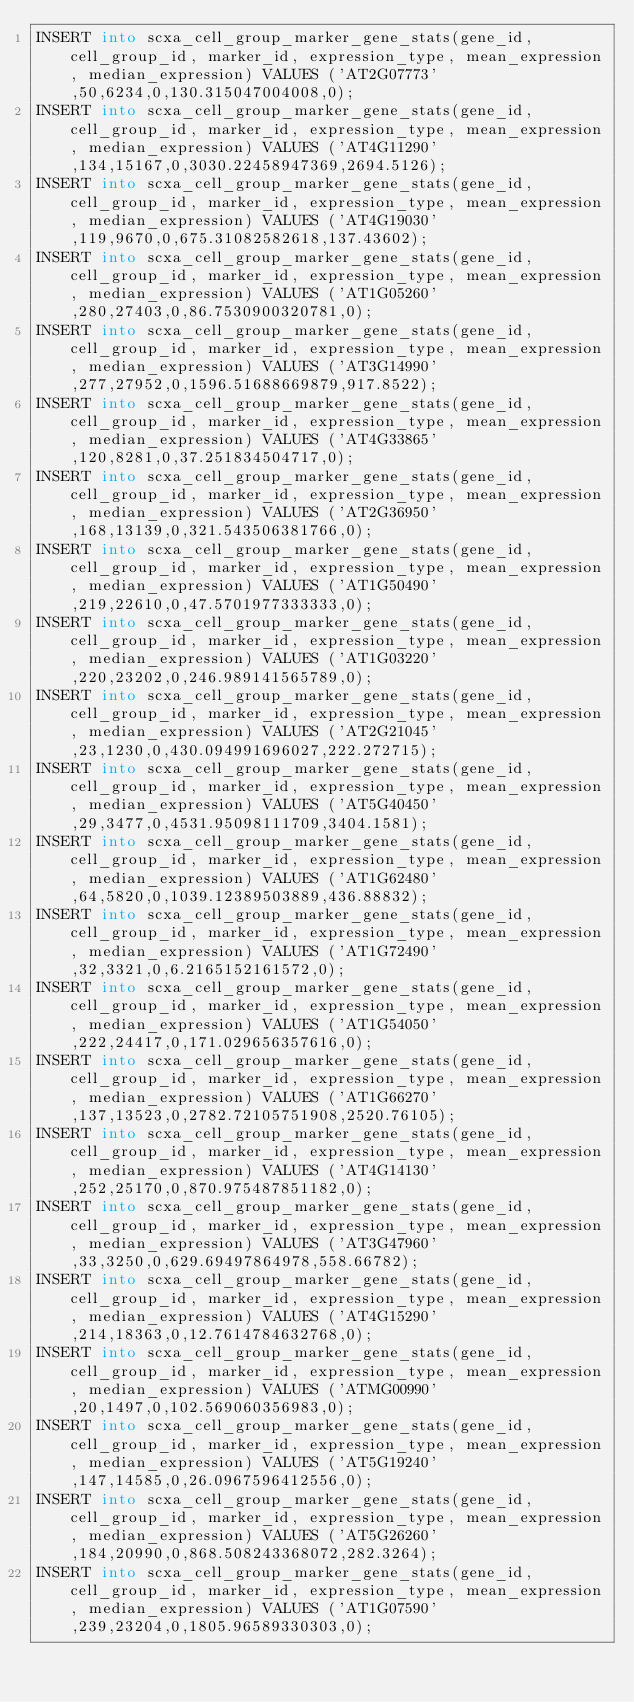Convert code to text. <code><loc_0><loc_0><loc_500><loc_500><_SQL_>INSERT into scxa_cell_group_marker_gene_stats(gene_id, cell_group_id, marker_id, expression_type, mean_expression, median_expression) VALUES ('AT2G07773',50,6234,0,130.315047004008,0);
INSERT into scxa_cell_group_marker_gene_stats(gene_id, cell_group_id, marker_id, expression_type, mean_expression, median_expression) VALUES ('AT4G11290',134,15167,0,3030.22458947369,2694.5126);
INSERT into scxa_cell_group_marker_gene_stats(gene_id, cell_group_id, marker_id, expression_type, mean_expression, median_expression) VALUES ('AT4G19030',119,9670,0,675.31082582618,137.43602);
INSERT into scxa_cell_group_marker_gene_stats(gene_id, cell_group_id, marker_id, expression_type, mean_expression, median_expression) VALUES ('AT1G05260',280,27403,0,86.7530900320781,0);
INSERT into scxa_cell_group_marker_gene_stats(gene_id, cell_group_id, marker_id, expression_type, mean_expression, median_expression) VALUES ('AT3G14990',277,27952,0,1596.51688669879,917.8522);
INSERT into scxa_cell_group_marker_gene_stats(gene_id, cell_group_id, marker_id, expression_type, mean_expression, median_expression) VALUES ('AT4G33865',120,8281,0,37.251834504717,0);
INSERT into scxa_cell_group_marker_gene_stats(gene_id, cell_group_id, marker_id, expression_type, mean_expression, median_expression) VALUES ('AT2G36950',168,13139,0,321.543506381766,0);
INSERT into scxa_cell_group_marker_gene_stats(gene_id, cell_group_id, marker_id, expression_type, mean_expression, median_expression) VALUES ('AT1G50490',219,22610,0,47.5701977333333,0);
INSERT into scxa_cell_group_marker_gene_stats(gene_id, cell_group_id, marker_id, expression_type, mean_expression, median_expression) VALUES ('AT1G03220',220,23202,0,246.989141565789,0);
INSERT into scxa_cell_group_marker_gene_stats(gene_id, cell_group_id, marker_id, expression_type, mean_expression, median_expression) VALUES ('AT2G21045',23,1230,0,430.094991696027,222.272715);
INSERT into scxa_cell_group_marker_gene_stats(gene_id, cell_group_id, marker_id, expression_type, mean_expression, median_expression) VALUES ('AT5G40450',29,3477,0,4531.95098111709,3404.1581);
INSERT into scxa_cell_group_marker_gene_stats(gene_id, cell_group_id, marker_id, expression_type, mean_expression, median_expression) VALUES ('AT1G62480',64,5820,0,1039.12389503889,436.88832);
INSERT into scxa_cell_group_marker_gene_stats(gene_id, cell_group_id, marker_id, expression_type, mean_expression, median_expression) VALUES ('AT1G72490',32,3321,0,6.2165152161572,0);
INSERT into scxa_cell_group_marker_gene_stats(gene_id, cell_group_id, marker_id, expression_type, mean_expression, median_expression) VALUES ('AT1G54050',222,24417,0,171.029656357616,0);
INSERT into scxa_cell_group_marker_gene_stats(gene_id, cell_group_id, marker_id, expression_type, mean_expression, median_expression) VALUES ('AT1G66270',137,13523,0,2782.72105751908,2520.76105);
INSERT into scxa_cell_group_marker_gene_stats(gene_id, cell_group_id, marker_id, expression_type, mean_expression, median_expression) VALUES ('AT4G14130',252,25170,0,870.975487851182,0);
INSERT into scxa_cell_group_marker_gene_stats(gene_id, cell_group_id, marker_id, expression_type, mean_expression, median_expression) VALUES ('AT3G47960',33,3250,0,629.69497864978,558.66782);
INSERT into scxa_cell_group_marker_gene_stats(gene_id, cell_group_id, marker_id, expression_type, mean_expression, median_expression) VALUES ('AT4G15290',214,18363,0,12.7614784632768,0);
INSERT into scxa_cell_group_marker_gene_stats(gene_id, cell_group_id, marker_id, expression_type, mean_expression, median_expression) VALUES ('ATMG00990',20,1497,0,102.569060356983,0);
INSERT into scxa_cell_group_marker_gene_stats(gene_id, cell_group_id, marker_id, expression_type, mean_expression, median_expression) VALUES ('AT5G19240',147,14585,0,26.0967596412556,0);
INSERT into scxa_cell_group_marker_gene_stats(gene_id, cell_group_id, marker_id, expression_type, mean_expression, median_expression) VALUES ('AT5G26260',184,20990,0,868.508243368072,282.3264);
INSERT into scxa_cell_group_marker_gene_stats(gene_id, cell_group_id, marker_id, expression_type, mean_expression, median_expression) VALUES ('AT1G07590',239,23204,0,1805.96589330303,0);</code> 